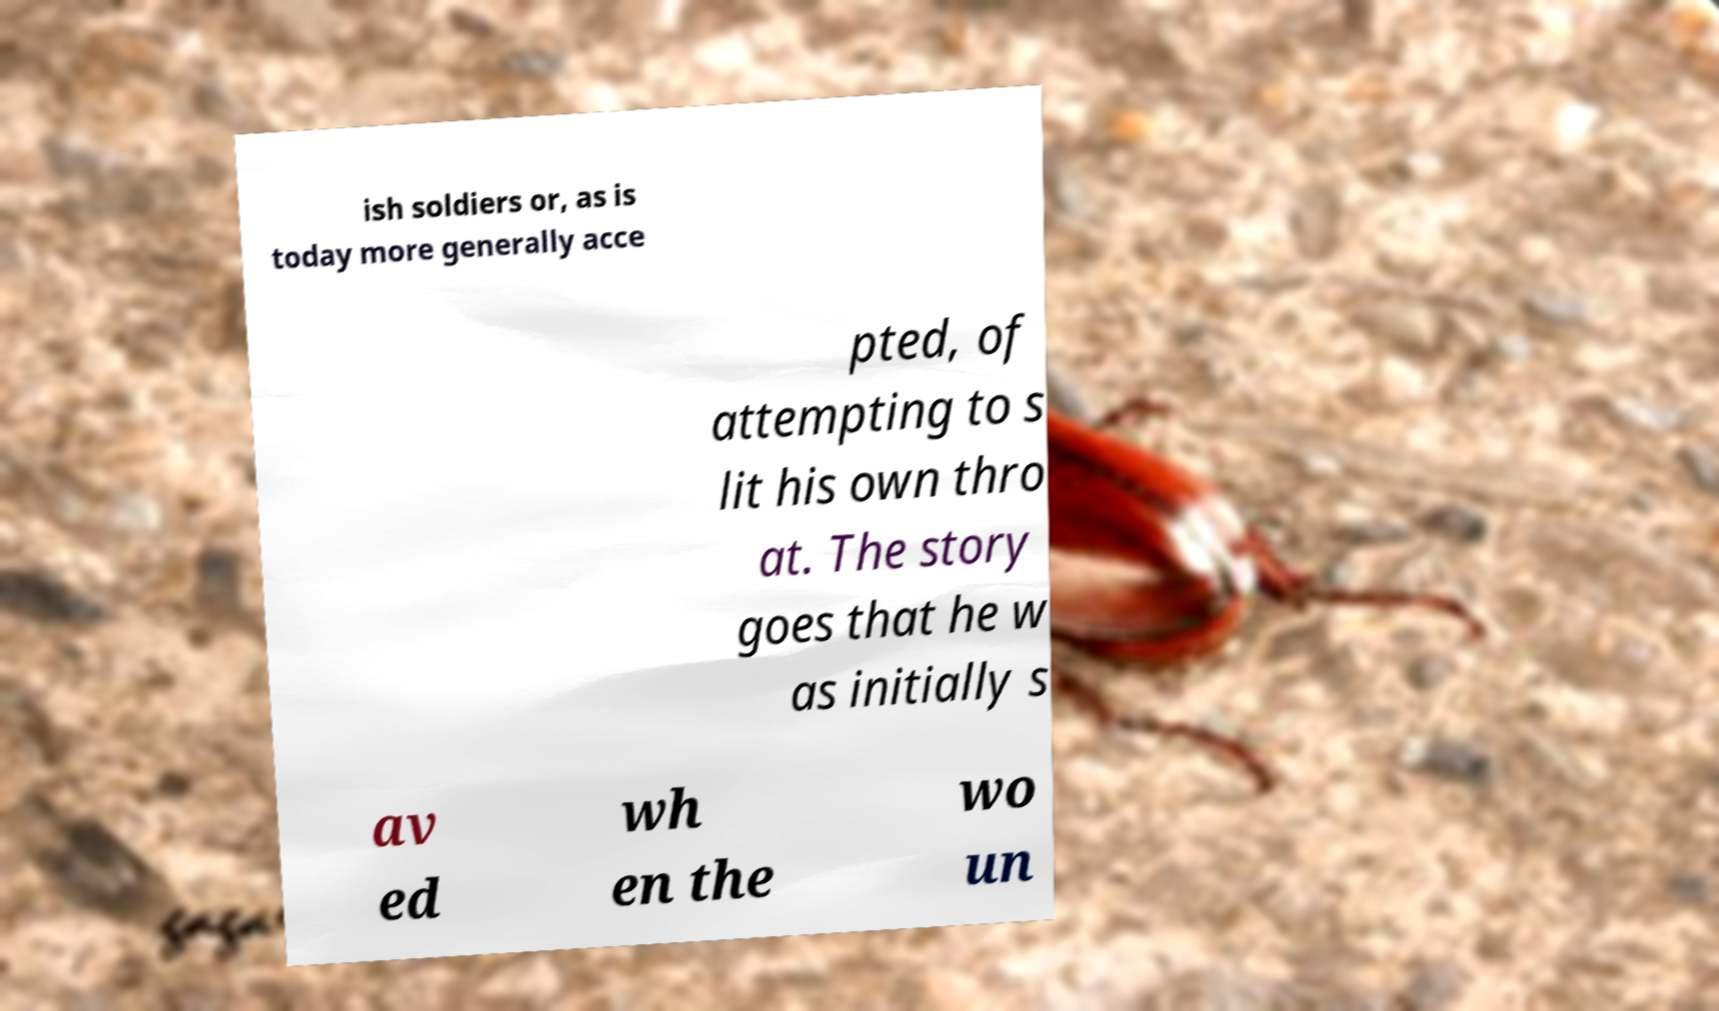Could you extract and type out the text from this image? ish soldiers or, as is today more generally acce pted, of attempting to s lit his own thro at. The story goes that he w as initially s av ed wh en the wo un 